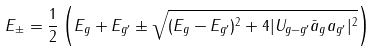<formula> <loc_0><loc_0><loc_500><loc_500>E _ { \pm } = \frac { 1 } { 2 } \left ( E _ { g } + E _ { g ^ { \prime } } \pm \sqrt { ( E _ { g } - E _ { g ^ { \prime } } ) ^ { 2 } + 4 | U _ { g - { g } ^ { \prime } } \bar { a } _ { g } a _ { g ^ { \prime } } | ^ { 2 } } \right )</formula> 